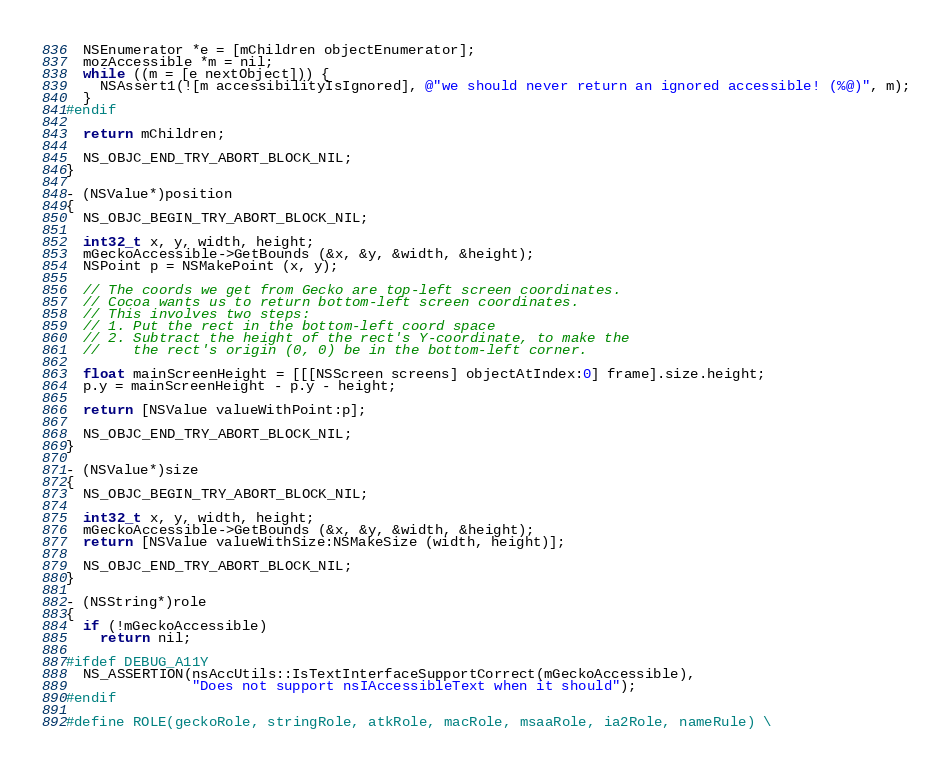<code> <loc_0><loc_0><loc_500><loc_500><_ObjectiveC_>  NSEnumerator *e = [mChildren objectEnumerator];
  mozAccessible *m = nil;
  while ((m = [e nextObject])) {
    NSAssert1(![m accessibilityIsIgnored], @"we should never return an ignored accessible! (%@)", m);
  }
#endif
  
  return mChildren;

  NS_OBJC_END_TRY_ABORT_BLOCK_NIL;
}

- (NSValue*)position
{
  NS_OBJC_BEGIN_TRY_ABORT_BLOCK_NIL;

  int32_t x, y, width, height;
  mGeckoAccessible->GetBounds (&x, &y, &width, &height);
  NSPoint p = NSMakePoint (x, y);
  
  // The coords we get from Gecko are top-left screen coordinates.
  // Cocoa wants us to return bottom-left screen coordinates.
  // This involves two steps:
  // 1. Put the rect in the bottom-left coord space
  // 2. Subtract the height of the rect's Y-coordinate, to make the
  //    the rect's origin (0, 0) be in the bottom-left corner.
  
  float mainScreenHeight = [[[NSScreen screens] objectAtIndex:0] frame].size.height;
  p.y = mainScreenHeight - p.y - height;
  
  return [NSValue valueWithPoint:p];

  NS_OBJC_END_TRY_ABORT_BLOCK_NIL;
}

- (NSValue*)size
{
  NS_OBJC_BEGIN_TRY_ABORT_BLOCK_NIL;

  int32_t x, y, width, height;
  mGeckoAccessible->GetBounds (&x, &y, &width, &height);  
  return [NSValue valueWithSize:NSMakeSize (width, height)];

  NS_OBJC_END_TRY_ABORT_BLOCK_NIL;
}

- (NSString*)role
{
  if (!mGeckoAccessible)
    return nil;

#ifdef DEBUG_A11Y
  NS_ASSERTION(nsAccUtils::IsTextInterfaceSupportCorrect(mGeckoAccessible),
               "Does not support nsIAccessibleText when it should");
#endif

#define ROLE(geckoRole, stringRole, atkRole, macRole, msaaRole, ia2Role, nameRule) \</code> 